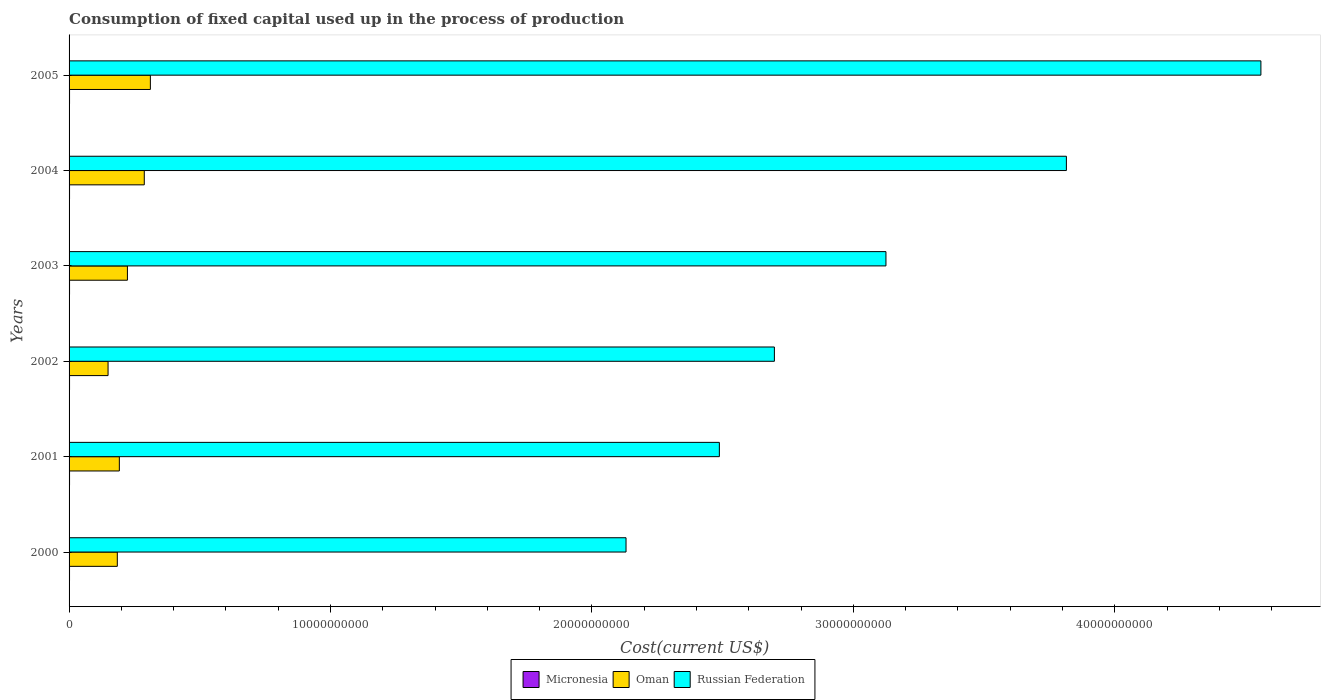How many groups of bars are there?
Keep it short and to the point. 6. Are the number of bars per tick equal to the number of legend labels?
Offer a very short reply. Yes. Are the number of bars on each tick of the Y-axis equal?
Ensure brevity in your answer.  Yes. How many bars are there on the 5th tick from the top?
Provide a succinct answer. 3. What is the label of the 6th group of bars from the top?
Offer a terse response. 2000. In how many cases, is the number of bars for a given year not equal to the number of legend labels?
Ensure brevity in your answer.  0. What is the amount consumed in the process of production in Micronesia in 2000?
Provide a short and direct response. 1.78e+07. Across all years, what is the maximum amount consumed in the process of production in Micronesia?
Your answer should be very brief. 1.85e+07. Across all years, what is the minimum amount consumed in the process of production in Micronesia?
Your answer should be compact. 1.78e+07. In which year was the amount consumed in the process of production in Oman minimum?
Your answer should be compact. 2002. What is the total amount consumed in the process of production in Micronesia in the graph?
Keep it short and to the point. 1.09e+08. What is the difference between the amount consumed in the process of production in Russian Federation in 2000 and that in 2004?
Provide a short and direct response. -1.68e+1. What is the difference between the amount consumed in the process of production in Russian Federation in 2004 and the amount consumed in the process of production in Oman in 2001?
Ensure brevity in your answer.  3.62e+1. What is the average amount consumed in the process of production in Oman per year?
Ensure brevity in your answer.  2.25e+09. In the year 2005, what is the difference between the amount consumed in the process of production in Micronesia and amount consumed in the process of production in Russian Federation?
Make the answer very short. -4.56e+1. What is the ratio of the amount consumed in the process of production in Russian Federation in 2003 to that in 2005?
Give a very brief answer. 0.69. Is the difference between the amount consumed in the process of production in Micronesia in 2000 and 2001 greater than the difference between the amount consumed in the process of production in Russian Federation in 2000 and 2001?
Make the answer very short. Yes. What is the difference between the highest and the second highest amount consumed in the process of production in Russian Federation?
Your answer should be very brief. 7.44e+09. What is the difference between the highest and the lowest amount consumed in the process of production in Russian Federation?
Offer a very short reply. 2.43e+1. In how many years, is the amount consumed in the process of production in Russian Federation greater than the average amount consumed in the process of production in Russian Federation taken over all years?
Your answer should be compact. 2. Is the sum of the amount consumed in the process of production in Russian Federation in 2000 and 2002 greater than the maximum amount consumed in the process of production in Micronesia across all years?
Offer a very short reply. Yes. What does the 3rd bar from the top in 2004 represents?
Provide a short and direct response. Micronesia. What does the 3rd bar from the bottom in 2000 represents?
Offer a terse response. Russian Federation. Is it the case that in every year, the sum of the amount consumed in the process of production in Micronesia and amount consumed in the process of production in Oman is greater than the amount consumed in the process of production in Russian Federation?
Ensure brevity in your answer.  No. How many bars are there?
Ensure brevity in your answer.  18. How many years are there in the graph?
Provide a short and direct response. 6. Does the graph contain any zero values?
Your response must be concise. No. Does the graph contain grids?
Give a very brief answer. No. Where does the legend appear in the graph?
Make the answer very short. Bottom center. What is the title of the graph?
Provide a succinct answer. Consumption of fixed capital used up in the process of production. Does "Pacific island small states" appear as one of the legend labels in the graph?
Offer a terse response. No. What is the label or title of the X-axis?
Ensure brevity in your answer.  Cost(current US$). What is the label or title of the Y-axis?
Offer a very short reply. Years. What is the Cost(current US$) in Micronesia in 2000?
Provide a succinct answer. 1.78e+07. What is the Cost(current US$) of Oman in 2000?
Make the answer very short. 1.85e+09. What is the Cost(current US$) of Russian Federation in 2000?
Give a very brief answer. 2.13e+1. What is the Cost(current US$) in Micronesia in 2001?
Provide a succinct answer. 1.84e+07. What is the Cost(current US$) of Oman in 2001?
Keep it short and to the point. 1.92e+09. What is the Cost(current US$) of Russian Federation in 2001?
Your answer should be compact. 2.49e+1. What is the Cost(current US$) of Micronesia in 2002?
Give a very brief answer. 1.81e+07. What is the Cost(current US$) in Oman in 2002?
Your response must be concise. 1.49e+09. What is the Cost(current US$) in Russian Federation in 2002?
Provide a succinct answer. 2.70e+1. What is the Cost(current US$) of Micronesia in 2003?
Ensure brevity in your answer.  1.85e+07. What is the Cost(current US$) in Oman in 2003?
Keep it short and to the point. 2.23e+09. What is the Cost(current US$) in Russian Federation in 2003?
Keep it short and to the point. 3.12e+1. What is the Cost(current US$) of Micronesia in 2004?
Give a very brief answer. 1.82e+07. What is the Cost(current US$) of Oman in 2004?
Provide a short and direct response. 2.88e+09. What is the Cost(current US$) in Russian Federation in 2004?
Your answer should be compact. 3.82e+1. What is the Cost(current US$) in Micronesia in 2005?
Your answer should be very brief. 1.83e+07. What is the Cost(current US$) of Oman in 2005?
Keep it short and to the point. 3.11e+09. What is the Cost(current US$) of Russian Federation in 2005?
Make the answer very short. 4.56e+1. Across all years, what is the maximum Cost(current US$) of Micronesia?
Your answer should be very brief. 1.85e+07. Across all years, what is the maximum Cost(current US$) of Oman?
Your answer should be very brief. 3.11e+09. Across all years, what is the maximum Cost(current US$) in Russian Federation?
Your answer should be very brief. 4.56e+1. Across all years, what is the minimum Cost(current US$) in Micronesia?
Provide a succinct answer. 1.78e+07. Across all years, what is the minimum Cost(current US$) of Oman?
Provide a succinct answer. 1.49e+09. Across all years, what is the minimum Cost(current US$) of Russian Federation?
Provide a succinct answer. 2.13e+1. What is the total Cost(current US$) in Micronesia in the graph?
Your response must be concise. 1.09e+08. What is the total Cost(current US$) in Oman in the graph?
Your response must be concise. 1.35e+1. What is the total Cost(current US$) of Russian Federation in the graph?
Ensure brevity in your answer.  1.88e+11. What is the difference between the Cost(current US$) of Micronesia in 2000 and that in 2001?
Keep it short and to the point. -6.39e+05. What is the difference between the Cost(current US$) in Oman in 2000 and that in 2001?
Your answer should be very brief. -7.76e+07. What is the difference between the Cost(current US$) of Russian Federation in 2000 and that in 2001?
Offer a terse response. -3.57e+09. What is the difference between the Cost(current US$) of Micronesia in 2000 and that in 2002?
Offer a very short reply. -3.52e+05. What is the difference between the Cost(current US$) of Oman in 2000 and that in 2002?
Your response must be concise. 3.54e+08. What is the difference between the Cost(current US$) in Russian Federation in 2000 and that in 2002?
Keep it short and to the point. -5.68e+09. What is the difference between the Cost(current US$) in Micronesia in 2000 and that in 2003?
Your answer should be compact. -6.75e+05. What is the difference between the Cost(current US$) in Oman in 2000 and that in 2003?
Give a very brief answer. -3.87e+08. What is the difference between the Cost(current US$) of Russian Federation in 2000 and that in 2003?
Your response must be concise. -9.94e+09. What is the difference between the Cost(current US$) of Micronesia in 2000 and that in 2004?
Provide a short and direct response. -3.68e+05. What is the difference between the Cost(current US$) in Oman in 2000 and that in 2004?
Your response must be concise. -1.03e+09. What is the difference between the Cost(current US$) in Russian Federation in 2000 and that in 2004?
Give a very brief answer. -1.68e+1. What is the difference between the Cost(current US$) in Micronesia in 2000 and that in 2005?
Your answer should be very brief. -5.16e+05. What is the difference between the Cost(current US$) in Oman in 2000 and that in 2005?
Your answer should be very brief. -1.26e+09. What is the difference between the Cost(current US$) of Russian Federation in 2000 and that in 2005?
Provide a short and direct response. -2.43e+1. What is the difference between the Cost(current US$) of Micronesia in 2001 and that in 2002?
Provide a succinct answer. 2.87e+05. What is the difference between the Cost(current US$) of Oman in 2001 and that in 2002?
Offer a very short reply. 4.32e+08. What is the difference between the Cost(current US$) of Russian Federation in 2001 and that in 2002?
Ensure brevity in your answer.  -2.10e+09. What is the difference between the Cost(current US$) of Micronesia in 2001 and that in 2003?
Offer a very short reply. -3.57e+04. What is the difference between the Cost(current US$) in Oman in 2001 and that in 2003?
Offer a terse response. -3.09e+08. What is the difference between the Cost(current US$) in Russian Federation in 2001 and that in 2003?
Make the answer very short. -6.37e+09. What is the difference between the Cost(current US$) of Micronesia in 2001 and that in 2004?
Give a very brief answer. 2.71e+05. What is the difference between the Cost(current US$) in Oman in 2001 and that in 2004?
Offer a very short reply. -9.53e+08. What is the difference between the Cost(current US$) of Russian Federation in 2001 and that in 2004?
Ensure brevity in your answer.  -1.33e+1. What is the difference between the Cost(current US$) of Micronesia in 2001 and that in 2005?
Your answer should be compact. 1.23e+05. What is the difference between the Cost(current US$) in Oman in 2001 and that in 2005?
Keep it short and to the point. -1.19e+09. What is the difference between the Cost(current US$) in Russian Federation in 2001 and that in 2005?
Make the answer very short. -2.07e+1. What is the difference between the Cost(current US$) of Micronesia in 2002 and that in 2003?
Offer a terse response. -3.22e+05. What is the difference between the Cost(current US$) of Oman in 2002 and that in 2003?
Keep it short and to the point. -7.41e+08. What is the difference between the Cost(current US$) in Russian Federation in 2002 and that in 2003?
Your answer should be compact. -4.27e+09. What is the difference between the Cost(current US$) in Micronesia in 2002 and that in 2004?
Offer a terse response. -1.58e+04. What is the difference between the Cost(current US$) in Oman in 2002 and that in 2004?
Provide a short and direct response. -1.39e+09. What is the difference between the Cost(current US$) of Russian Federation in 2002 and that in 2004?
Offer a very short reply. -1.12e+1. What is the difference between the Cost(current US$) in Micronesia in 2002 and that in 2005?
Make the answer very short. -1.63e+05. What is the difference between the Cost(current US$) in Oman in 2002 and that in 2005?
Offer a terse response. -1.62e+09. What is the difference between the Cost(current US$) in Russian Federation in 2002 and that in 2005?
Offer a very short reply. -1.86e+1. What is the difference between the Cost(current US$) of Micronesia in 2003 and that in 2004?
Your response must be concise. 3.07e+05. What is the difference between the Cost(current US$) of Oman in 2003 and that in 2004?
Make the answer very short. -6.44e+08. What is the difference between the Cost(current US$) in Russian Federation in 2003 and that in 2004?
Ensure brevity in your answer.  -6.90e+09. What is the difference between the Cost(current US$) of Micronesia in 2003 and that in 2005?
Provide a short and direct response. 1.59e+05. What is the difference between the Cost(current US$) of Oman in 2003 and that in 2005?
Your response must be concise. -8.78e+08. What is the difference between the Cost(current US$) of Russian Federation in 2003 and that in 2005?
Your answer should be very brief. -1.43e+1. What is the difference between the Cost(current US$) in Micronesia in 2004 and that in 2005?
Give a very brief answer. -1.48e+05. What is the difference between the Cost(current US$) in Oman in 2004 and that in 2005?
Offer a terse response. -2.33e+08. What is the difference between the Cost(current US$) in Russian Federation in 2004 and that in 2005?
Your response must be concise. -7.44e+09. What is the difference between the Cost(current US$) of Micronesia in 2000 and the Cost(current US$) of Oman in 2001?
Ensure brevity in your answer.  -1.91e+09. What is the difference between the Cost(current US$) of Micronesia in 2000 and the Cost(current US$) of Russian Federation in 2001?
Keep it short and to the point. -2.49e+1. What is the difference between the Cost(current US$) of Oman in 2000 and the Cost(current US$) of Russian Federation in 2001?
Your answer should be very brief. -2.30e+1. What is the difference between the Cost(current US$) of Micronesia in 2000 and the Cost(current US$) of Oman in 2002?
Make the answer very short. -1.47e+09. What is the difference between the Cost(current US$) of Micronesia in 2000 and the Cost(current US$) of Russian Federation in 2002?
Offer a terse response. -2.70e+1. What is the difference between the Cost(current US$) of Oman in 2000 and the Cost(current US$) of Russian Federation in 2002?
Your response must be concise. -2.51e+1. What is the difference between the Cost(current US$) in Micronesia in 2000 and the Cost(current US$) in Oman in 2003?
Your answer should be very brief. -2.21e+09. What is the difference between the Cost(current US$) of Micronesia in 2000 and the Cost(current US$) of Russian Federation in 2003?
Your answer should be very brief. -3.12e+1. What is the difference between the Cost(current US$) in Oman in 2000 and the Cost(current US$) in Russian Federation in 2003?
Provide a succinct answer. -2.94e+1. What is the difference between the Cost(current US$) of Micronesia in 2000 and the Cost(current US$) of Oman in 2004?
Ensure brevity in your answer.  -2.86e+09. What is the difference between the Cost(current US$) in Micronesia in 2000 and the Cost(current US$) in Russian Federation in 2004?
Give a very brief answer. -3.81e+1. What is the difference between the Cost(current US$) of Oman in 2000 and the Cost(current US$) of Russian Federation in 2004?
Your answer should be compact. -3.63e+1. What is the difference between the Cost(current US$) of Micronesia in 2000 and the Cost(current US$) of Oman in 2005?
Offer a very short reply. -3.09e+09. What is the difference between the Cost(current US$) of Micronesia in 2000 and the Cost(current US$) of Russian Federation in 2005?
Your answer should be very brief. -4.56e+1. What is the difference between the Cost(current US$) of Oman in 2000 and the Cost(current US$) of Russian Federation in 2005?
Ensure brevity in your answer.  -4.37e+1. What is the difference between the Cost(current US$) in Micronesia in 2001 and the Cost(current US$) in Oman in 2002?
Offer a very short reply. -1.47e+09. What is the difference between the Cost(current US$) of Micronesia in 2001 and the Cost(current US$) of Russian Federation in 2002?
Provide a succinct answer. -2.70e+1. What is the difference between the Cost(current US$) in Oman in 2001 and the Cost(current US$) in Russian Federation in 2002?
Your response must be concise. -2.51e+1. What is the difference between the Cost(current US$) of Micronesia in 2001 and the Cost(current US$) of Oman in 2003?
Offer a terse response. -2.21e+09. What is the difference between the Cost(current US$) in Micronesia in 2001 and the Cost(current US$) in Russian Federation in 2003?
Give a very brief answer. -3.12e+1. What is the difference between the Cost(current US$) in Oman in 2001 and the Cost(current US$) in Russian Federation in 2003?
Offer a very short reply. -2.93e+1. What is the difference between the Cost(current US$) in Micronesia in 2001 and the Cost(current US$) in Oman in 2004?
Provide a short and direct response. -2.86e+09. What is the difference between the Cost(current US$) of Micronesia in 2001 and the Cost(current US$) of Russian Federation in 2004?
Make the answer very short. -3.81e+1. What is the difference between the Cost(current US$) in Oman in 2001 and the Cost(current US$) in Russian Federation in 2004?
Your answer should be very brief. -3.62e+1. What is the difference between the Cost(current US$) in Micronesia in 2001 and the Cost(current US$) in Oman in 2005?
Offer a very short reply. -3.09e+09. What is the difference between the Cost(current US$) of Micronesia in 2001 and the Cost(current US$) of Russian Federation in 2005?
Keep it short and to the point. -4.56e+1. What is the difference between the Cost(current US$) of Oman in 2001 and the Cost(current US$) of Russian Federation in 2005?
Ensure brevity in your answer.  -4.37e+1. What is the difference between the Cost(current US$) in Micronesia in 2002 and the Cost(current US$) in Oman in 2003?
Keep it short and to the point. -2.21e+09. What is the difference between the Cost(current US$) of Micronesia in 2002 and the Cost(current US$) of Russian Federation in 2003?
Your response must be concise. -3.12e+1. What is the difference between the Cost(current US$) in Oman in 2002 and the Cost(current US$) in Russian Federation in 2003?
Offer a very short reply. -2.98e+1. What is the difference between the Cost(current US$) in Micronesia in 2002 and the Cost(current US$) in Oman in 2004?
Provide a succinct answer. -2.86e+09. What is the difference between the Cost(current US$) of Micronesia in 2002 and the Cost(current US$) of Russian Federation in 2004?
Keep it short and to the point. -3.81e+1. What is the difference between the Cost(current US$) of Oman in 2002 and the Cost(current US$) of Russian Federation in 2004?
Give a very brief answer. -3.67e+1. What is the difference between the Cost(current US$) of Micronesia in 2002 and the Cost(current US$) of Oman in 2005?
Provide a short and direct response. -3.09e+09. What is the difference between the Cost(current US$) of Micronesia in 2002 and the Cost(current US$) of Russian Federation in 2005?
Your response must be concise. -4.56e+1. What is the difference between the Cost(current US$) in Oman in 2002 and the Cost(current US$) in Russian Federation in 2005?
Your answer should be compact. -4.41e+1. What is the difference between the Cost(current US$) of Micronesia in 2003 and the Cost(current US$) of Oman in 2004?
Keep it short and to the point. -2.86e+09. What is the difference between the Cost(current US$) in Micronesia in 2003 and the Cost(current US$) in Russian Federation in 2004?
Offer a terse response. -3.81e+1. What is the difference between the Cost(current US$) of Oman in 2003 and the Cost(current US$) of Russian Federation in 2004?
Make the answer very short. -3.59e+1. What is the difference between the Cost(current US$) in Micronesia in 2003 and the Cost(current US$) in Oman in 2005?
Your answer should be compact. -3.09e+09. What is the difference between the Cost(current US$) in Micronesia in 2003 and the Cost(current US$) in Russian Federation in 2005?
Offer a terse response. -4.56e+1. What is the difference between the Cost(current US$) in Oman in 2003 and the Cost(current US$) in Russian Federation in 2005?
Offer a terse response. -4.34e+1. What is the difference between the Cost(current US$) of Micronesia in 2004 and the Cost(current US$) of Oman in 2005?
Provide a succinct answer. -3.09e+09. What is the difference between the Cost(current US$) of Micronesia in 2004 and the Cost(current US$) of Russian Federation in 2005?
Your response must be concise. -4.56e+1. What is the difference between the Cost(current US$) of Oman in 2004 and the Cost(current US$) of Russian Federation in 2005?
Give a very brief answer. -4.27e+1. What is the average Cost(current US$) in Micronesia per year?
Keep it short and to the point. 1.82e+07. What is the average Cost(current US$) of Oman per year?
Give a very brief answer. 2.25e+09. What is the average Cost(current US$) of Russian Federation per year?
Keep it short and to the point. 3.14e+1. In the year 2000, what is the difference between the Cost(current US$) of Micronesia and Cost(current US$) of Oman?
Your answer should be compact. -1.83e+09. In the year 2000, what is the difference between the Cost(current US$) in Micronesia and Cost(current US$) in Russian Federation?
Make the answer very short. -2.13e+1. In the year 2000, what is the difference between the Cost(current US$) of Oman and Cost(current US$) of Russian Federation?
Keep it short and to the point. -1.95e+1. In the year 2001, what is the difference between the Cost(current US$) in Micronesia and Cost(current US$) in Oman?
Offer a terse response. -1.90e+09. In the year 2001, what is the difference between the Cost(current US$) in Micronesia and Cost(current US$) in Russian Federation?
Offer a very short reply. -2.49e+1. In the year 2001, what is the difference between the Cost(current US$) of Oman and Cost(current US$) of Russian Federation?
Keep it short and to the point. -2.30e+1. In the year 2002, what is the difference between the Cost(current US$) in Micronesia and Cost(current US$) in Oman?
Offer a very short reply. -1.47e+09. In the year 2002, what is the difference between the Cost(current US$) in Micronesia and Cost(current US$) in Russian Federation?
Keep it short and to the point. -2.70e+1. In the year 2002, what is the difference between the Cost(current US$) in Oman and Cost(current US$) in Russian Federation?
Offer a terse response. -2.55e+1. In the year 2003, what is the difference between the Cost(current US$) of Micronesia and Cost(current US$) of Oman?
Provide a short and direct response. -2.21e+09. In the year 2003, what is the difference between the Cost(current US$) in Micronesia and Cost(current US$) in Russian Federation?
Your response must be concise. -3.12e+1. In the year 2003, what is the difference between the Cost(current US$) of Oman and Cost(current US$) of Russian Federation?
Keep it short and to the point. -2.90e+1. In the year 2004, what is the difference between the Cost(current US$) in Micronesia and Cost(current US$) in Oman?
Give a very brief answer. -2.86e+09. In the year 2004, what is the difference between the Cost(current US$) of Micronesia and Cost(current US$) of Russian Federation?
Offer a very short reply. -3.81e+1. In the year 2004, what is the difference between the Cost(current US$) of Oman and Cost(current US$) of Russian Federation?
Offer a terse response. -3.53e+1. In the year 2005, what is the difference between the Cost(current US$) in Micronesia and Cost(current US$) in Oman?
Ensure brevity in your answer.  -3.09e+09. In the year 2005, what is the difference between the Cost(current US$) in Micronesia and Cost(current US$) in Russian Federation?
Keep it short and to the point. -4.56e+1. In the year 2005, what is the difference between the Cost(current US$) in Oman and Cost(current US$) in Russian Federation?
Your answer should be very brief. -4.25e+1. What is the ratio of the Cost(current US$) of Micronesia in 2000 to that in 2001?
Make the answer very short. 0.97. What is the ratio of the Cost(current US$) in Oman in 2000 to that in 2001?
Your answer should be compact. 0.96. What is the ratio of the Cost(current US$) of Russian Federation in 2000 to that in 2001?
Provide a short and direct response. 0.86. What is the ratio of the Cost(current US$) of Micronesia in 2000 to that in 2002?
Offer a very short reply. 0.98. What is the ratio of the Cost(current US$) in Oman in 2000 to that in 2002?
Offer a terse response. 1.24. What is the ratio of the Cost(current US$) of Russian Federation in 2000 to that in 2002?
Give a very brief answer. 0.79. What is the ratio of the Cost(current US$) of Micronesia in 2000 to that in 2003?
Your response must be concise. 0.96. What is the ratio of the Cost(current US$) in Oman in 2000 to that in 2003?
Give a very brief answer. 0.83. What is the ratio of the Cost(current US$) of Russian Federation in 2000 to that in 2003?
Give a very brief answer. 0.68. What is the ratio of the Cost(current US$) in Micronesia in 2000 to that in 2004?
Give a very brief answer. 0.98. What is the ratio of the Cost(current US$) in Oman in 2000 to that in 2004?
Provide a short and direct response. 0.64. What is the ratio of the Cost(current US$) in Russian Federation in 2000 to that in 2004?
Ensure brevity in your answer.  0.56. What is the ratio of the Cost(current US$) in Micronesia in 2000 to that in 2005?
Your answer should be very brief. 0.97. What is the ratio of the Cost(current US$) of Oman in 2000 to that in 2005?
Provide a short and direct response. 0.59. What is the ratio of the Cost(current US$) of Russian Federation in 2000 to that in 2005?
Offer a terse response. 0.47. What is the ratio of the Cost(current US$) in Micronesia in 2001 to that in 2002?
Provide a short and direct response. 1.02. What is the ratio of the Cost(current US$) of Oman in 2001 to that in 2002?
Your response must be concise. 1.29. What is the ratio of the Cost(current US$) in Russian Federation in 2001 to that in 2002?
Make the answer very short. 0.92. What is the ratio of the Cost(current US$) in Oman in 2001 to that in 2003?
Your answer should be very brief. 0.86. What is the ratio of the Cost(current US$) of Russian Federation in 2001 to that in 2003?
Make the answer very short. 0.8. What is the ratio of the Cost(current US$) of Micronesia in 2001 to that in 2004?
Ensure brevity in your answer.  1.01. What is the ratio of the Cost(current US$) of Oman in 2001 to that in 2004?
Offer a terse response. 0.67. What is the ratio of the Cost(current US$) in Russian Federation in 2001 to that in 2004?
Offer a very short reply. 0.65. What is the ratio of the Cost(current US$) in Oman in 2001 to that in 2005?
Offer a terse response. 0.62. What is the ratio of the Cost(current US$) in Russian Federation in 2001 to that in 2005?
Keep it short and to the point. 0.55. What is the ratio of the Cost(current US$) in Micronesia in 2002 to that in 2003?
Offer a terse response. 0.98. What is the ratio of the Cost(current US$) of Oman in 2002 to that in 2003?
Give a very brief answer. 0.67. What is the ratio of the Cost(current US$) in Russian Federation in 2002 to that in 2003?
Give a very brief answer. 0.86. What is the ratio of the Cost(current US$) of Micronesia in 2002 to that in 2004?
Provide a succinct answer. 1. What is the ratio of the Cost(current US$) in Oman in 2002 to that in 2004?
Keep it short and to the point. 0.52. What is the ratio of the Cost(current US$) of Russian Federation in 2002 to that in 2004?
Your answer should be very brief. 0.71. What is the ratio of the Cost(current US$) of Oman in 2002 to that in 2005?
Offer a terse response. 0.48. What is the ratio of the Cost(current US$) in Russian Federation in 2002 to that in 2005?
Your answer should be very brief. 0.59. What is the ratio of the Cost(current US$) of Micronesia in 2003 to that in 2004?
Your response must be concise. 1.02. What is the ratio of the Cost(current US$) in Oman in 2003 to that in 2004?
Offer a terse response. 0.78. What is the ratio of the Cost(current US$) of Russian Federation in 2003 to that in 2004?
Your answer should be compact. 0.82. What is the ratio of the Cost(current US$) of Micronesia in 2003 to that in 2005?
Provide a short and direct response. 1.01. What is the ratio of the Cost(current US$) of Oman in 2003 to that in 2005?
Keep it short and to the point. 0.72. What is the ratio of the Cost(current US$) of Russian Federation in 2003 to that in 2005?
Give a very brief answer. 0.69. What is the ratio of the Cost(current US$) in Micronesia in 2004 to that in 2005?
Provide a succinct answer. 0.99. What is the ratio of the Cost(current US$) of Oman in 2004 to that in 2005?
Give a very brief answer. 0.93. What is the ratio of the Cost(current US$) of Russian Federation in 2004 to that in 2005?
Ensure brevity in your answer.  0.84. What is the difference between the highest and the second highest Cost(current US$) of Micronesia?
Ensure brevity in your answer.  3.57e+04. What is the difference between the highest and the second highest Cost(current US$) of Oman?
Ensure brevity in your answer.  2.33e+08. What is the difference between the highest and the second highest Cost(current US$) of Russian Federation?
Keep it short and to the point. 7.44e+09. What is the difference between the highest and the lowest Cost(current US$) of Micronesia?
Ensure brevity in your answer.  6.75e+05. What is the difference between the highest and the lowest Cost(current US$) in Oman?
Offer a terse response. 1.62e+09. What is the difference between the highest and the lowest Cost(current US$) in Russian Federation?
Keep it short and to the point. 2.43e+1. 